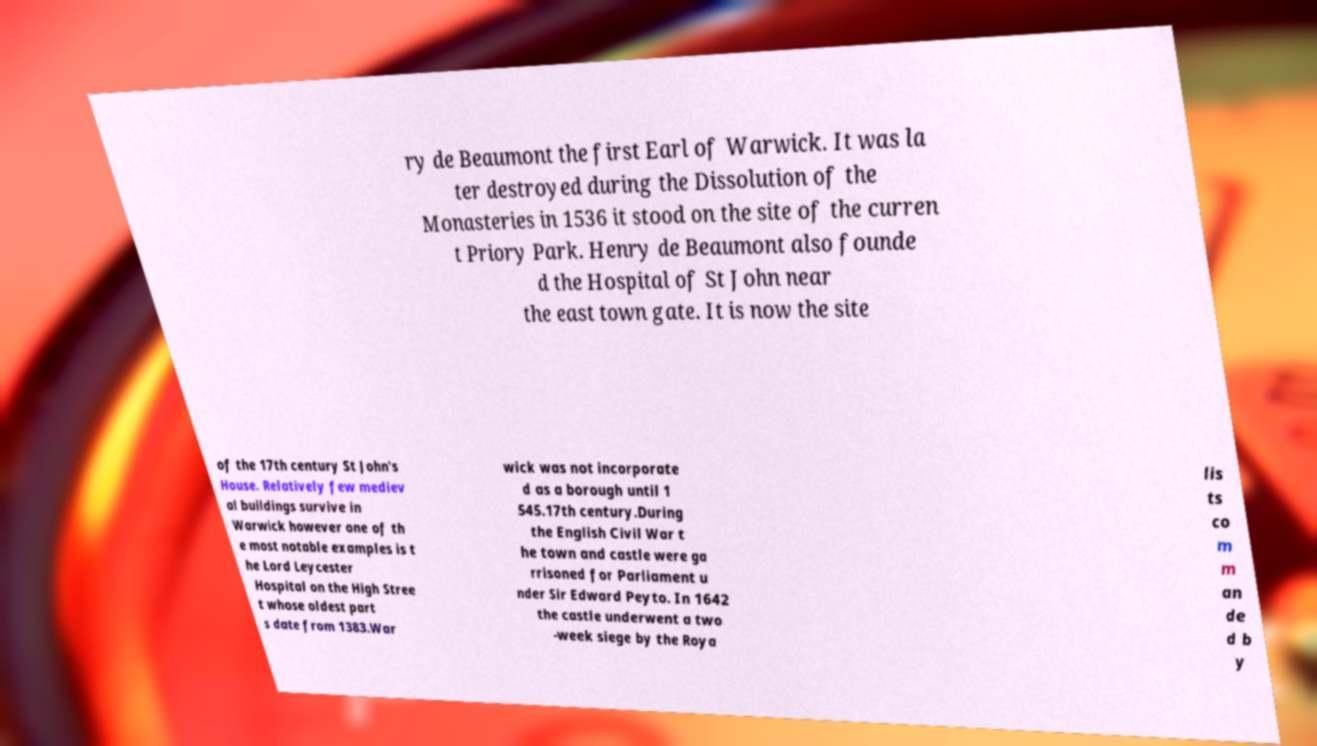What messages or text are displayed in this image? I need them in a readable, typed format. ry de Beaumont the first Earl of Warwick. It was la ter destroyed during the Dissolution of the Monasteries in 1536 it stood on the site of the curren t Priory Park. Henry de Beaumont also founde d the Hospital of St John near the east town gate. It is now the site of the 17th century St John's House. Relatively few mediev al buildings survive in Warwick however one of th e most notable examples is t he Lord Leycester Hospital on the High Stree t whose oldest part s date from 1383.War wick was not incorporate d as a borough until 1 545.17th century.During the English Civil War t he town and castle were ga rrisoned for Parliament u nder Sir Edward Peyto. In 1642 the castle underwent a two -week siege by the Roya lis ts co m m an de d b y 